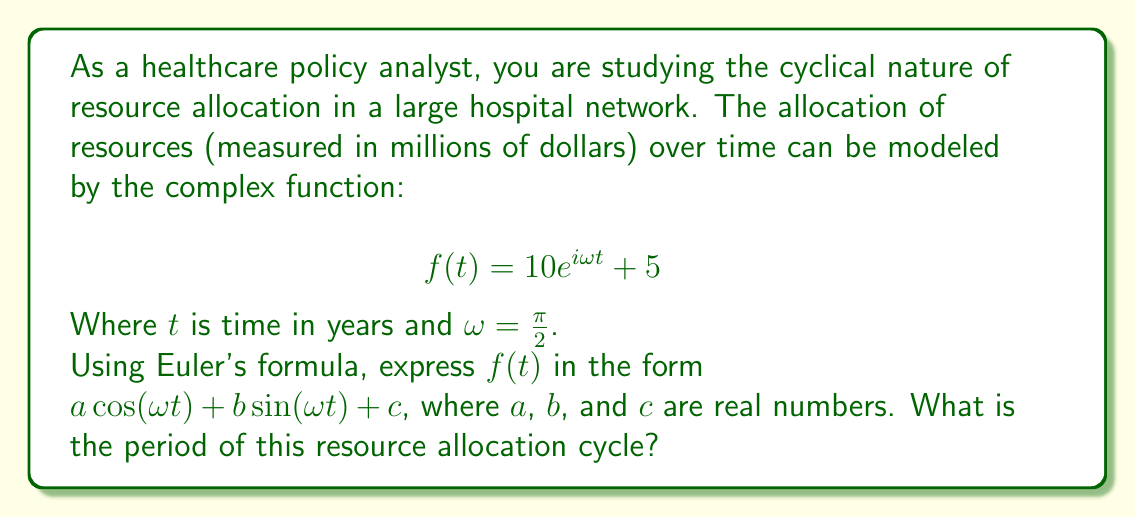What is the answer to this math problem? To solve this problem, we'll use Euler's formula and some properties of complex numbers:

1) Euler's formula states that $e^{ix} = \cos(x) + i\sin(x)$

2) In our case, $f(t) = 10e^{i\omega t} + 5$ where $\omega = \frac{\pi}{2}$

3) Applying Euler's formula:
   $$f(t) = 10(\cos(\omega t) + i\sin(\omega t)) + 5$$

4) Expanding:
   $$f(t) = 10\cos(\omega t) + 10i\sin(\omega t) + 5$$

5) Now we have $f(t)$ in the form $a\cos(\omega t) + b\sin(\omega t) + c$, where:
   $a = 10$
   $b = 10i$
   $c = 5$

6) To find the period, we use the formula: $T = \frac{2\pi}{\omega}$

7) Substituting $\omega = \frac{\pi}{2}$:
   $$T = \frac{2\pi}{\frac{\pi}{2}} = 4$$

Therefore, the period of the resource allocation cycle is 4 years.
Answer: $f(t) = 10\cos(\frac{\pi}{2}t) + 10i\sin(\frac{\pi}{2}t) + 5$

The period of the resource allocation cycle is 4 years. 